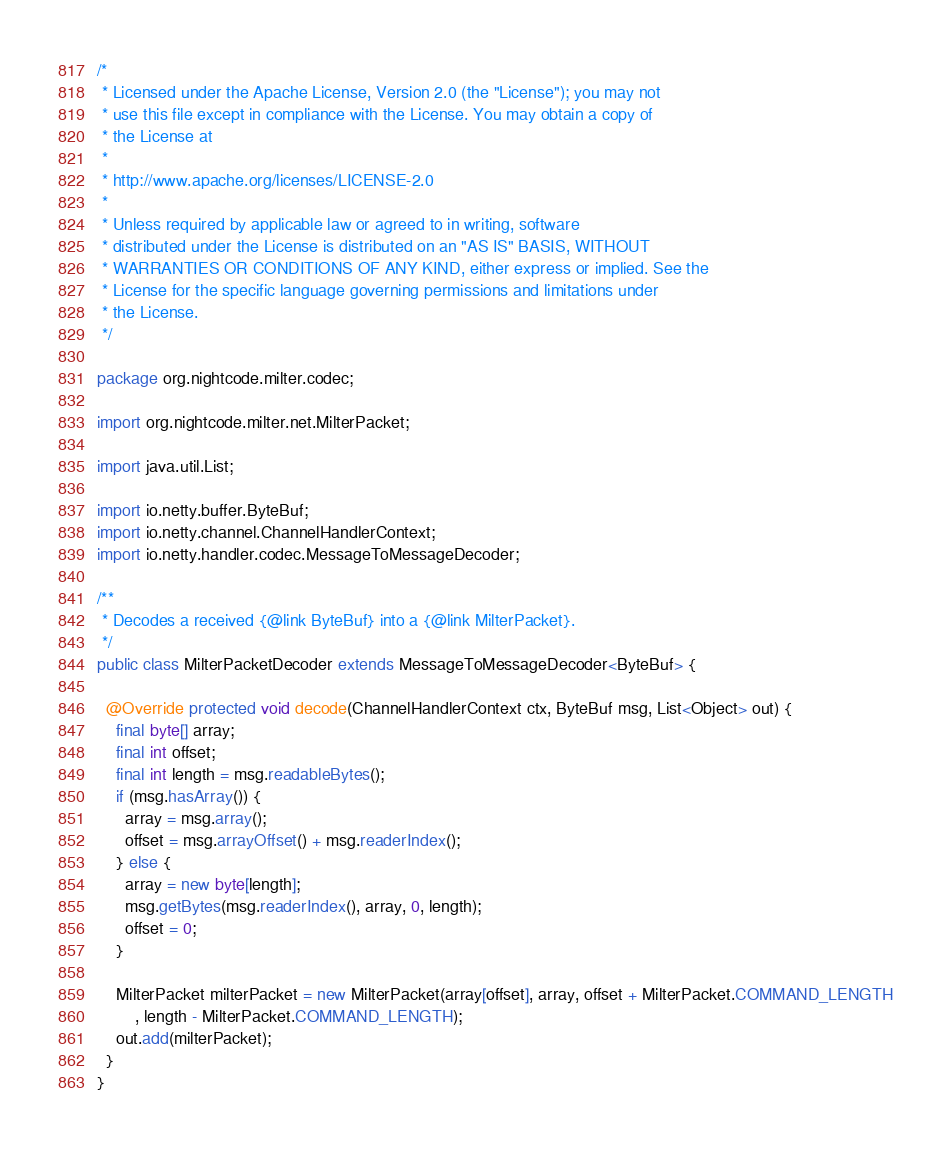Convert code to text. <code><loc_0><loc_0><loc_500><loc_500><_Java_>/*
 * Licensed under the Apache License, Version 2.0 (the "License"); you may not
 * use this file except in compliance with the License. You may obtain a copy of
 * the License at
 *
 * http://www.apache.org/licenses/LICENSE-2.0
 *
 * Unless required by applicable law or agreed to in writing, software
 * distributed under the License is distributed on an "AS IS" BASIS, WITHOUT
 * WARRANTIES OR CONDITIONS OF ANY KIND, either express or implied. See the
 * License for the specific language governing permissions and limitations under
 * the License.
 */

package org.nightcode.milter.codec;

import org.nightcode.milter.net.MilterPacket;

import java.util.List;

import io.netty.buffer.ByteBuf;
import io.netty.channel.ChannelHandlerContext;
import io.netty.handler.codec.MessageToMessageDecoder;

/**
 * Decodes a received {@link ByteBuf} into a {@link MilterPacket}.
 */
public class MilterPacketDecoder extends MessageToMessageDecoder<ByteBuf> {

  @Override protected void decode(ChannelHandlerContext ctx, ByteBuf msg, List<Object> out) {
    final byte[] array;
    final int offset;
    final int length = msg.readableBytes();
    if (msg.hasArray()) {
      array = msg.array();
      offset = msg.arrayOffset() + msg.readerIndex();
    } else {
      array = new byte[length];
      msg.getBytes(msg.readerIndex(), array, 0, length);
      offset = 0;
    }

    MilterPacket milterPacket = new MilterPacket(array[offset], array, offset + MilterPacket.COMMAND_LENGTH
        , length - MilterPacket.COMMAND_LENGTH);
    out.add(milterPacket);
  }
}
</code> 